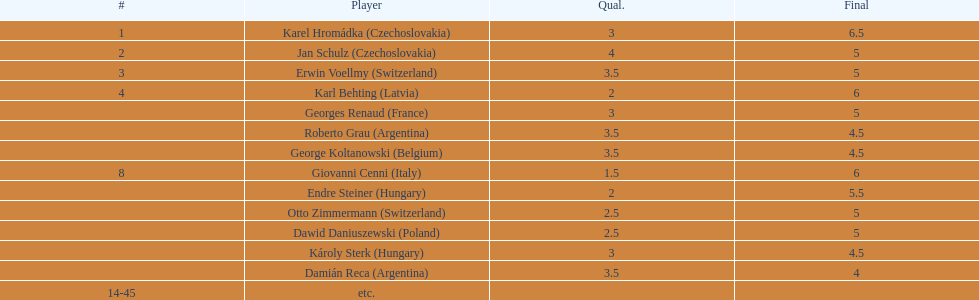Which player had the largest number of &#931; points? Karel Hromádka. 